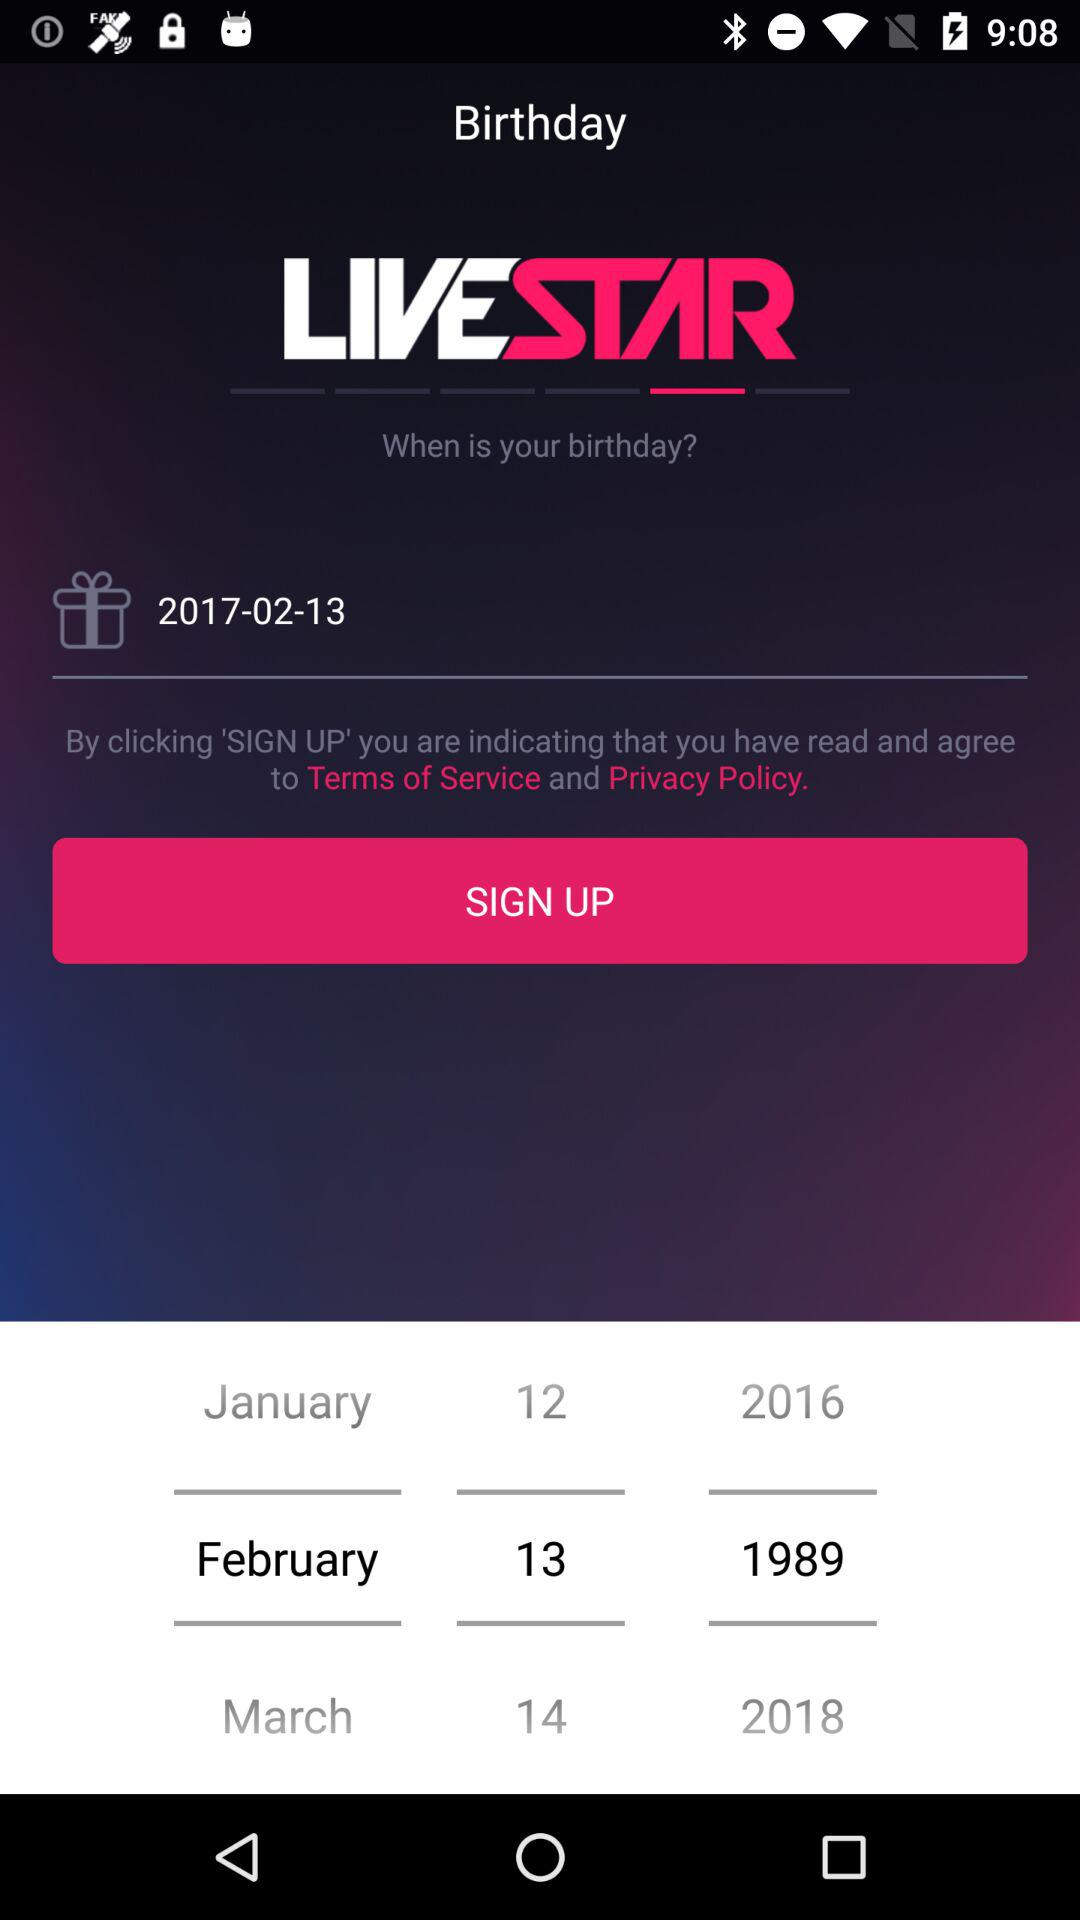What is the selected date? The selected date is February 13, 1989. 